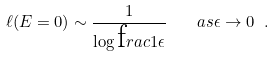<formula> <loc_0><loc_0><loc_500><loc_500>\ell ( E = 0 ) \sim \frac { 1 } { \log \text  frac{1} { \epsilon } } \quad a s \epsilon \rightarrow 0 \ .</formula> 